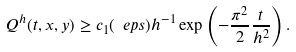<formula> <loc_0><loc_0><loc_500><loc_500>Q ^ { h } ( t , x , y ) \geq c _ { 1 } ( \ e p s ) h ^ { - 1 } \exp \left ( - \frac { \pi ^ { 2 } } { 2 } \frac { t } { h ^ { 2 } } \right ) .</formula> 